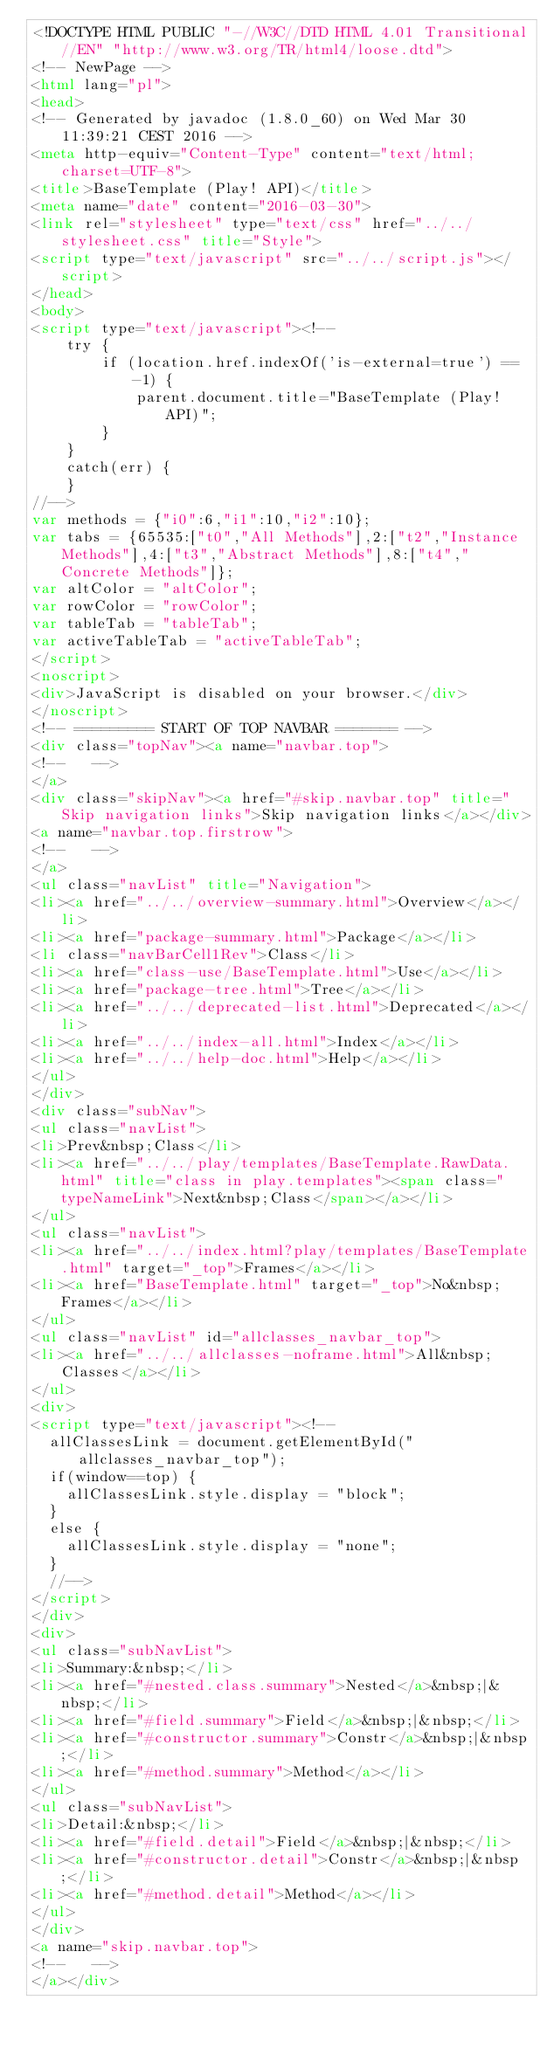<code> <loc_0><loc_0><loc_500><loc_500><_HTML_><!DOCTYPE HTML PUBLIC "-//W3C//DTD HTML 4.01 Transitional//EN" "http://www.w3.org/TR/html4/loose.dtd">
<!-- NewPage -->
<html lang="pl">
<head>
<!-- Generated by javadoc (1.8.0_60) on Wed Mar 30 11:39:21 CEST 2016 -->
<meta http-equiv="Content-Type" content="text/html; charset=UTF-8">
<title>BaseTemplate (Play! API)</title>
<meta name="date" content="2016-03-30">
<link rel="stylesheet" type="text/css" href="../../stylesheet.css" title="Style">
<script type="text/javascript" src="../../script.js"></script>
</head>
<body>
<script type="text/javascript"><!--
    try {
        if (location.href.indexOf('is-external=true') == -1) {
            parent.document.title="BaseTemplate (Play! API)";
        }
    }
    catch(err) {
    }
//-->
var methods = {"i0":6,"i1":10,"i2":10};
var tabs = {65535:["t0","All Methods"],2:["t2","Instance Methods"],4:["t3","Abstract Methods"],8:["t4","Concrete Methods"]};
var altColor = "altColor";
var rowColor = "rowColor";
var tableTab = "tableTab";
var activeTableTab = "activeTableTab";
</script>
<noscript>
<div>JavaScript is disabled on your browser.</div>
</noscript>
<!-- ========= START OF TOP NAVBAR ======= -->
<div class="topNav"><a name="navbar.top">
<!--   -->
</a>
<div class="skipNav"><a href="#skip.navbar.top" title="Skip navigation links">Skip navigation links</a></div>
<a name="navbar.top.firstrow">
<!--   -->
</a>
<ul class="navList" title="Navigation">
<li><a href="../../overview-summary.html">Overview</a></li>
<li><a href="package-summary.html">Package</a></li>
<li class="navBarCell1Rev">Class</li>
<li><a href="class-use/BaseTemplate.html">Use</a></li>
<li><a href="package-tree.html">Tree</a></li>
<li><a href="../../deprecated-list.html">Deprecated</a></li>
<li><a href="../../index-all.html">Index</a></li>
<li><a href="../../help-doc.html">Help</a></li>
</ul>
</div>
<div class="subNav">
<ul class="navList">
<li>Prev&nbsp;Class</li>
<li><a href="../../play/templates/BaseTemplate.RawData.html" title="class in play.templates"><span class="typeNameLink">Next&nbsp;Class</span></a></li>
</ul>
<ul class="navList">
<li><a href="../../index.html?play/templates/BaseTemplate.html" target="_top">Frames</a></li>
<li><a href="BaseTemplate.html" target="_top">No&nbsp;Frames</a></li>
</ul>
<ul class="navList" id="allclasses_navbar_top">
<li><a href="../../allclasses-noframe.html">All&nbsp;Classes</a></li>
</ul>
<div>
<script type="text/javascript"><!--
  allClassesLink = document.getElementById("allclasses_navbar_top");
  if(window==top) {
    allClassesLink.style.display = "block";
  }
  else {
    allClassesLink.style.display = "none";
  }
  //-->
</script>
</div>
<div>
<ul class="subNavList">
<li>Summary:&nbsp;</li>
<li><a href="#nested.class.summary">Nested</a>&nbsp;|&nbsp;</li>
<li><a href="#field.summary">Field</a>&nbsp;|&nbsp;</li>
<li><a href="#constructor.summary">Constr</a>&nbsp;|&nbsp;</li>
<li><a href="#method.summary">Method</a></li>
</ul>
<ul class="subNavList">
<li>Detail:&nbsp;</li>
<li><a href="#field.detail">Field</a>&nbsp;|&nbsp;</li>
<li><a href="#constructor.detail">Constr</a>&nbsp;|&nbsp;</li>
<li><a href="#method.detail">Method</a></li>
</ul>
</div>
<a name="skip.navbar.top">
<!--   -->
</a></div></code> 